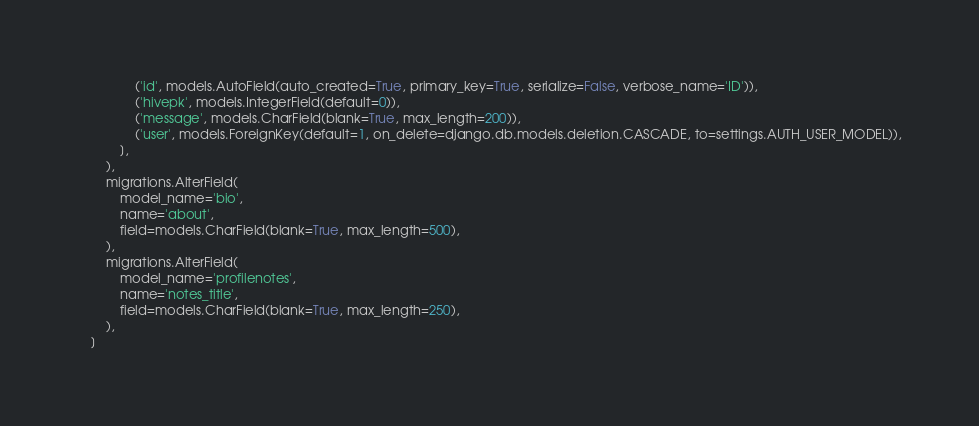<code> <loc_0><loc_0><loc_500><loc_500><_Python_>                ('id', models.AutoField(auto_created=True, primary_key=True, serialize=False, verbose_name='ID')),
                ('hivepk', models.IntegerField(default=0)),
                ('message', models.CharField(blank=True, max_length=200)),
                ('user', models.ForeignKey(default=1, on_delete=django.db.models.deletion.CASCADE, to=settings.AUTH_USER_MODEL)),
            ],
        ),
        migrations.AlterField(
            model_name='bio',
            name='about',
            field=models.CharField(blank=True, max_length=500),
        ),
        migrations.AlterField(
            model_name='profilenotes',
            name='notes_title',
            field=models.CharField(blank=True, max_length=250),
        ),
    ]
</code> 